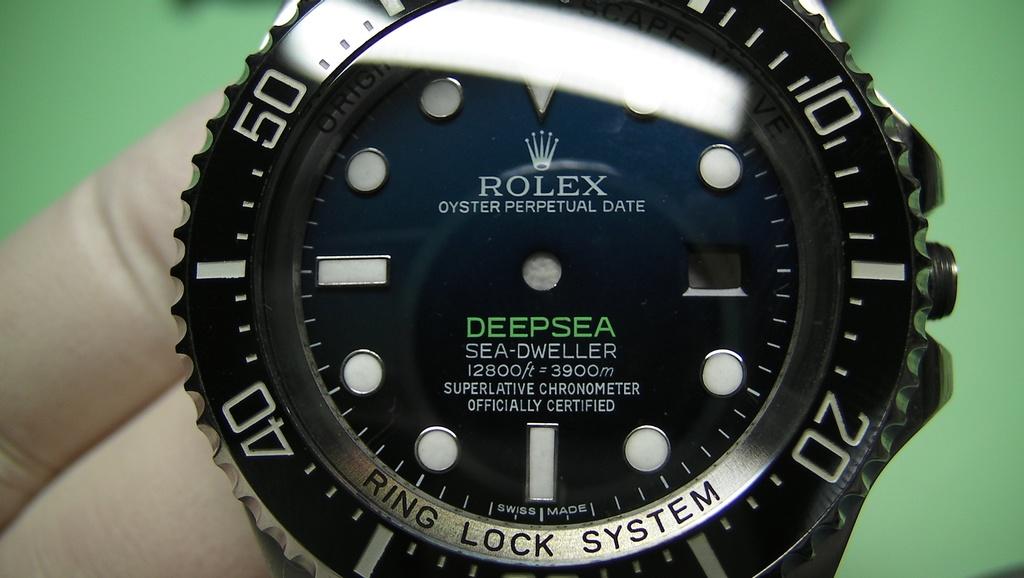What is the name in green?
Offer a terse response. Deepsea. 